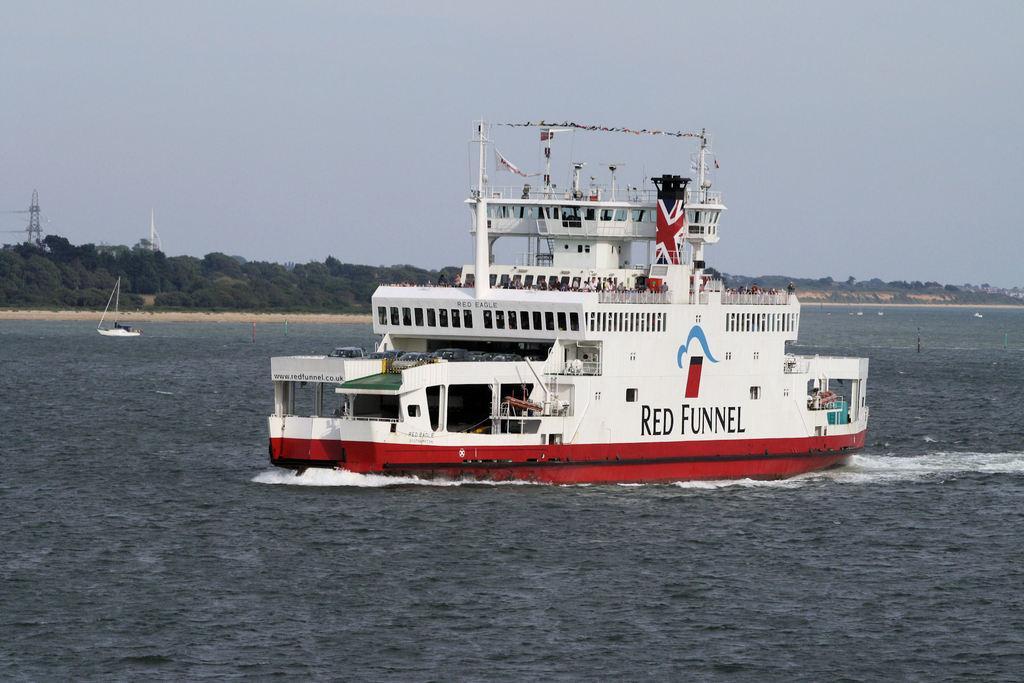In one or two sentences, can you explain what this image depicts? This is a ferry, which is moving on the water. This looks like a boat. These are the trees. I think this is a transmission tower. Here is the sky. 